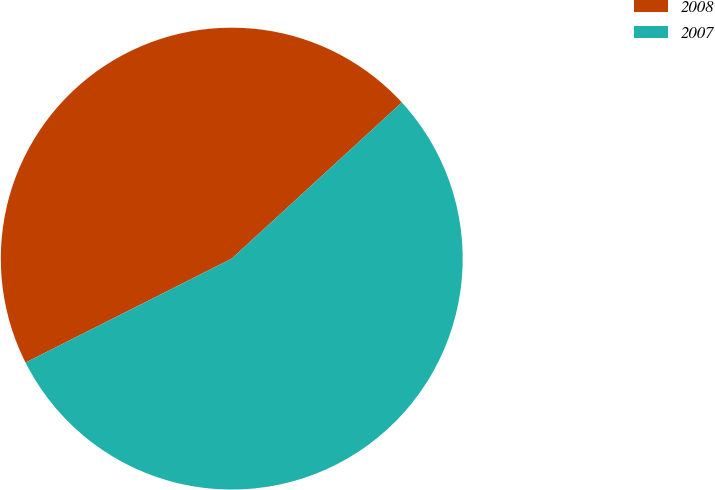<chart> <loc_0><loc_0><loc_500><loc_500><pie_chart><fcel>2008<fcel>2007<nl><fcel>45.61%<fcel>54.39%<nl></chart> 